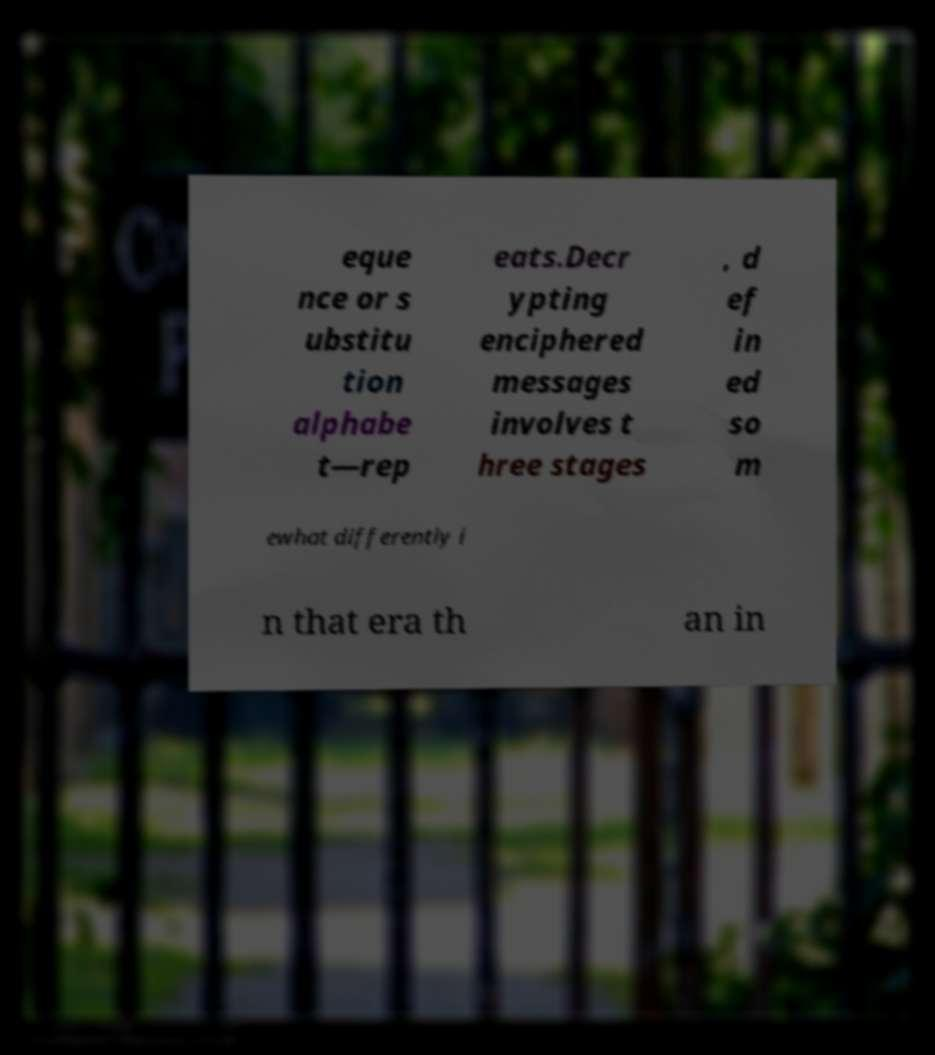Please identify and transcribe the text found in this image. eque nce or s ubstitu tion alphabe t—rep eats.Decr ypting enciphered messages involves t hree stages , d ef in ed so m ewhat differently i n that era th an in 